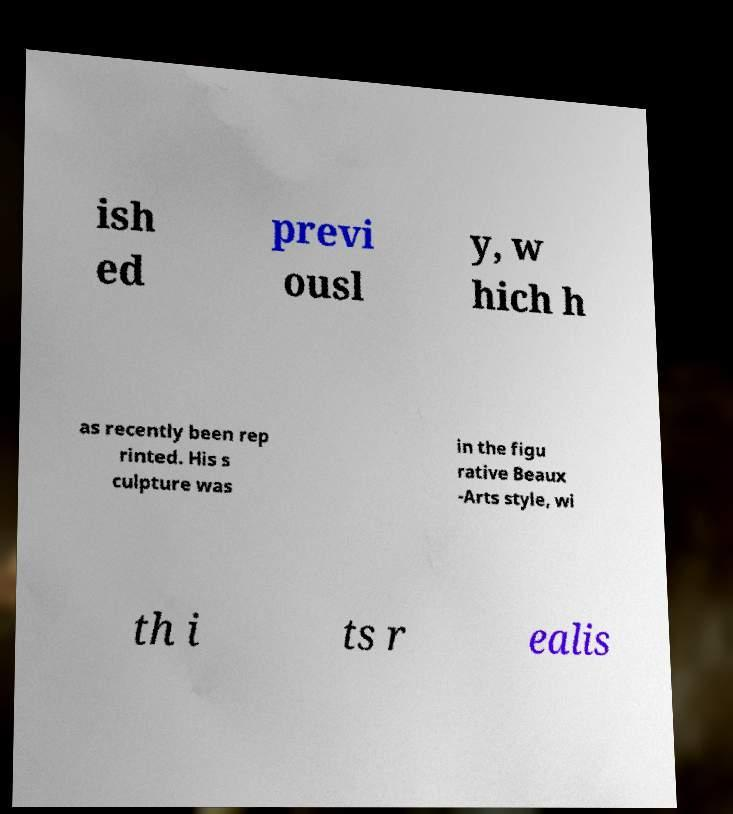Can you read and provide the text displayed in the image?This photo seems to have some interesting text. Can you extract and type it out for me? ish ed previ ousl y, w hich h as recently been rep rinted. His s culpture was in the figu rative Beaux -Arts style, wi th i ts r ealis 